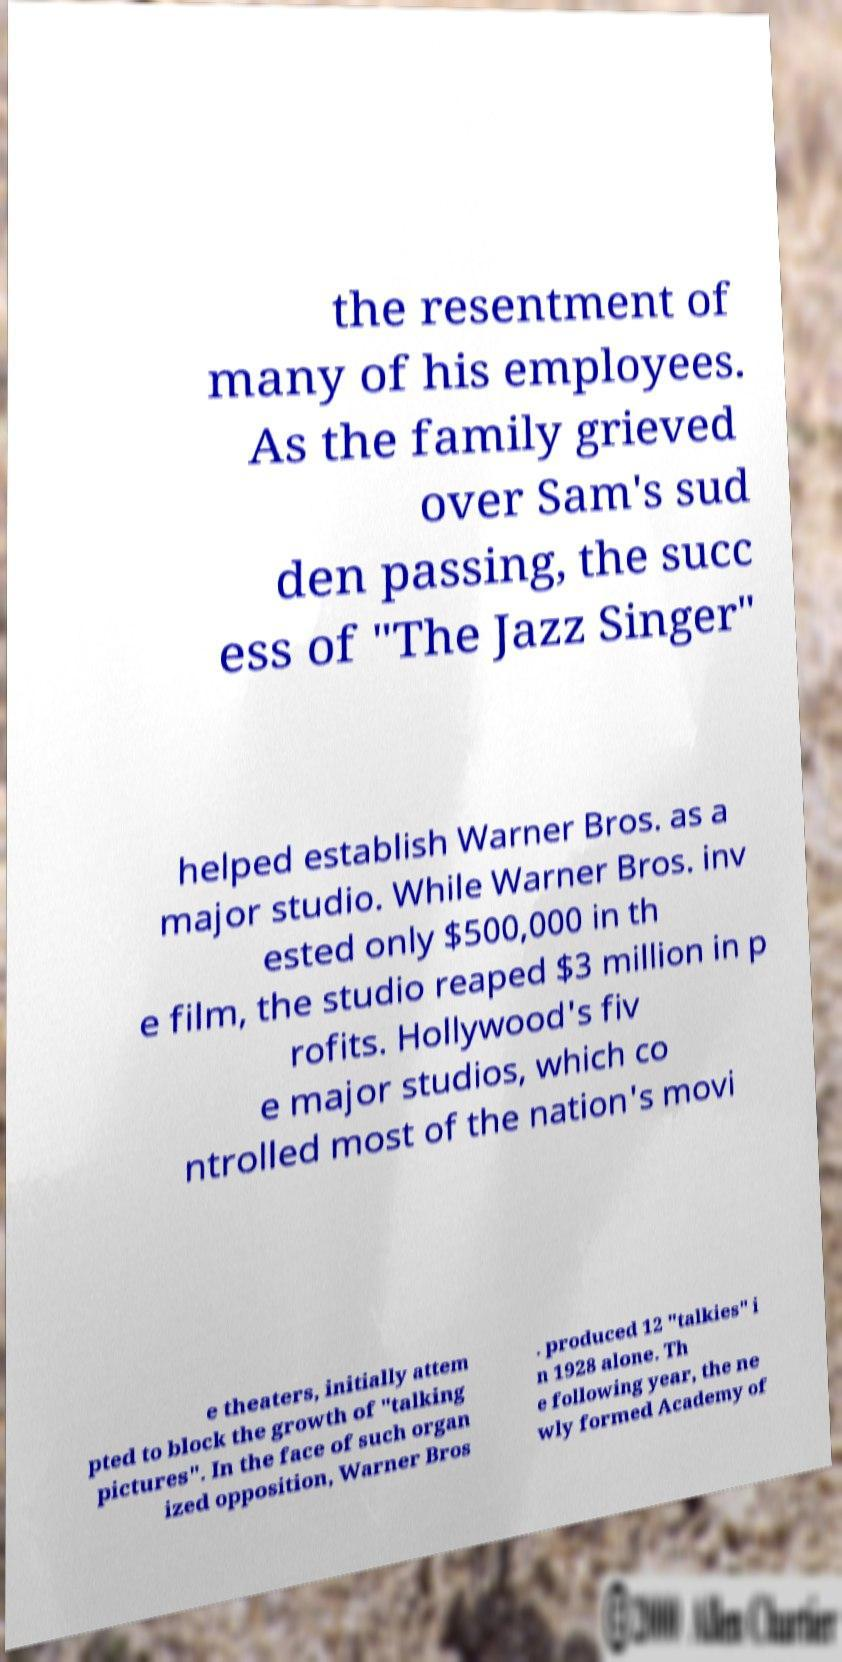Please identify and transcribe the text found in this image. the resentment of many of his employees. As the family grieved over Sam's sud den passing, the succ ess of "The Jazz Singer" helped establish Warner Bros. as a major studio. While Warner Bros. inv ested only $500,000 in th e film, the studio reaped $3 million in p rofits. Hollywood's fiv e major studios, which co ntrolled most of the nation's movi e theaters, initially attem pted to block the growth of "talking pictures". In the face of such organ ized opposition, Warner Bros . produced 12 "talkies" i n 1928 alone. Th e following year, the ne wly formed Academy of 